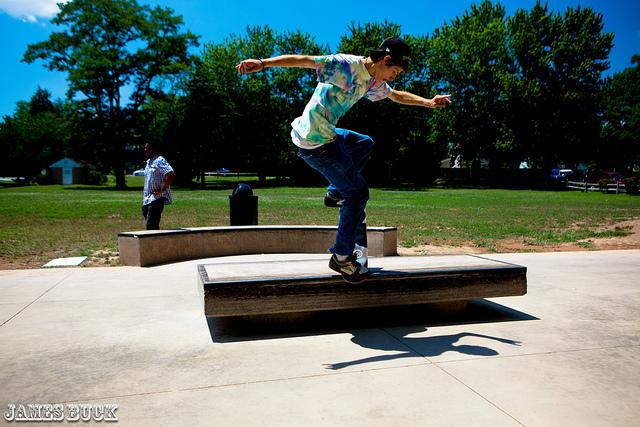In which space is this person boarding?

Choices:
A) inner city
B) tundra
C) park
D) desert park 